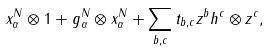Convert formula to latex. <formula><loc_0><loc_0><loc_500><loc_500>x _ { \alpha } ^ { N } \otimes 1 + g _ { \alpha } ^ { N } \otimes x _ { \alpha } ^ { N } + \sum _ { b , c } t _ { b , c } z ^ { b } h ^ { c } \otimes z ^ { c } ,</formula> 